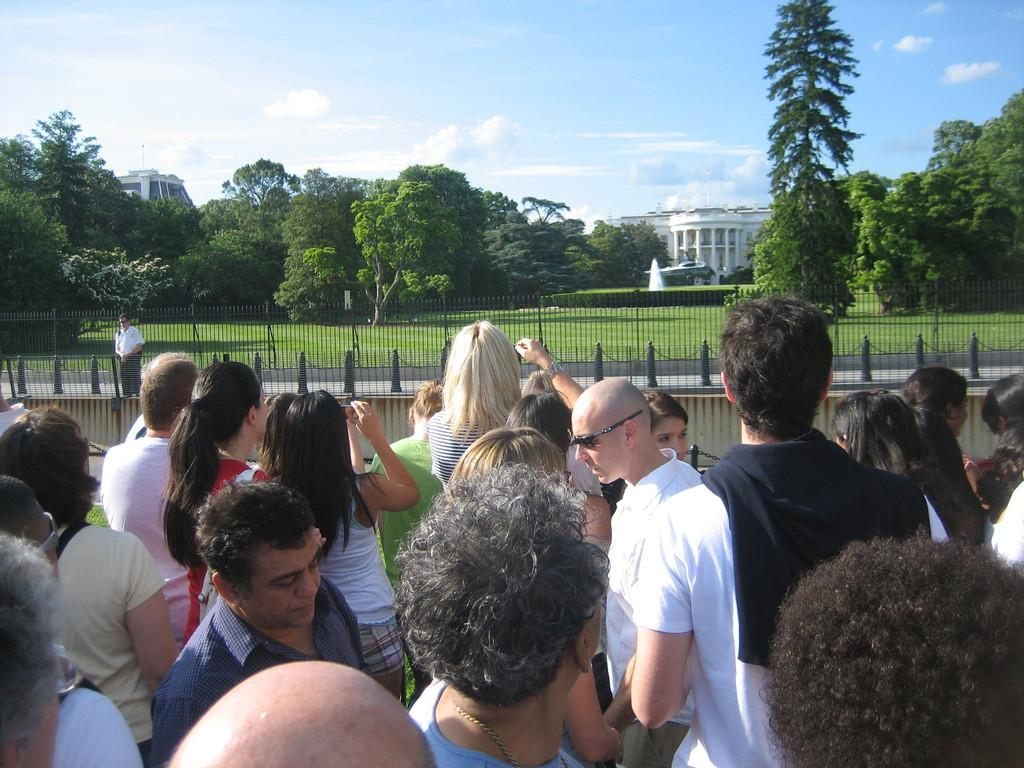How many people are in the image? There is a group of people standing in the image. What can be seen near the people in the image? There is railing visible in the image. What type of natural environment is present in the image? There is grass in the image. What can be seen in the distance in the image? There are trees and buildings in the background of the image, as well as clouds in the sky. What type of wax is being used to attack the trees in the image? There is no wax or attack present in the image; it features a group of people, railing, grass, trees, buildings, and clouds. 